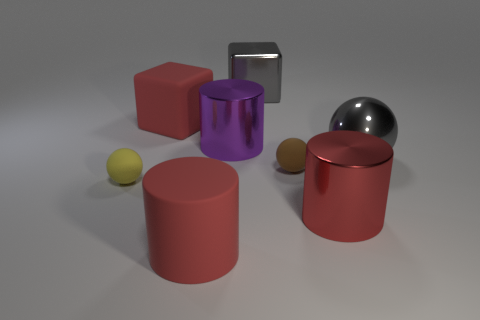Add 1 gray shiny balls. How many objects exist? 9 Subtract all cylinders. How many objects are left? 5 Add 6 big brown shiny cylinders. How many big brown shiny cylinders exist? 6 Subtract 2 red cylinders. How many objects are left? 6 Subtract all red matte cubes. Subtract all big red cubes. How many objects are left? 6 Add 7 red shiny objects. How many red shiny objects are left? 8 